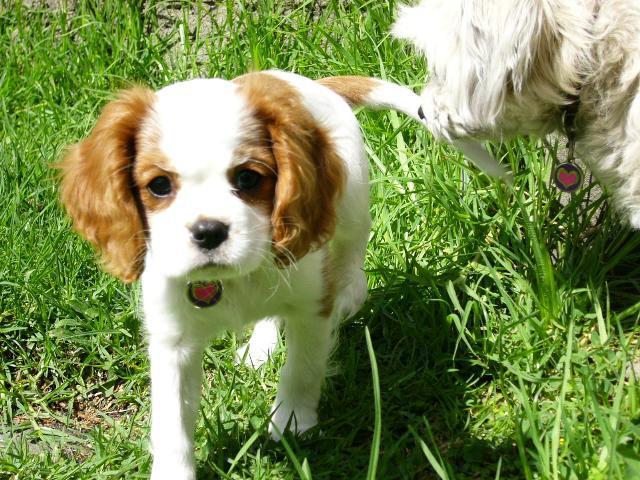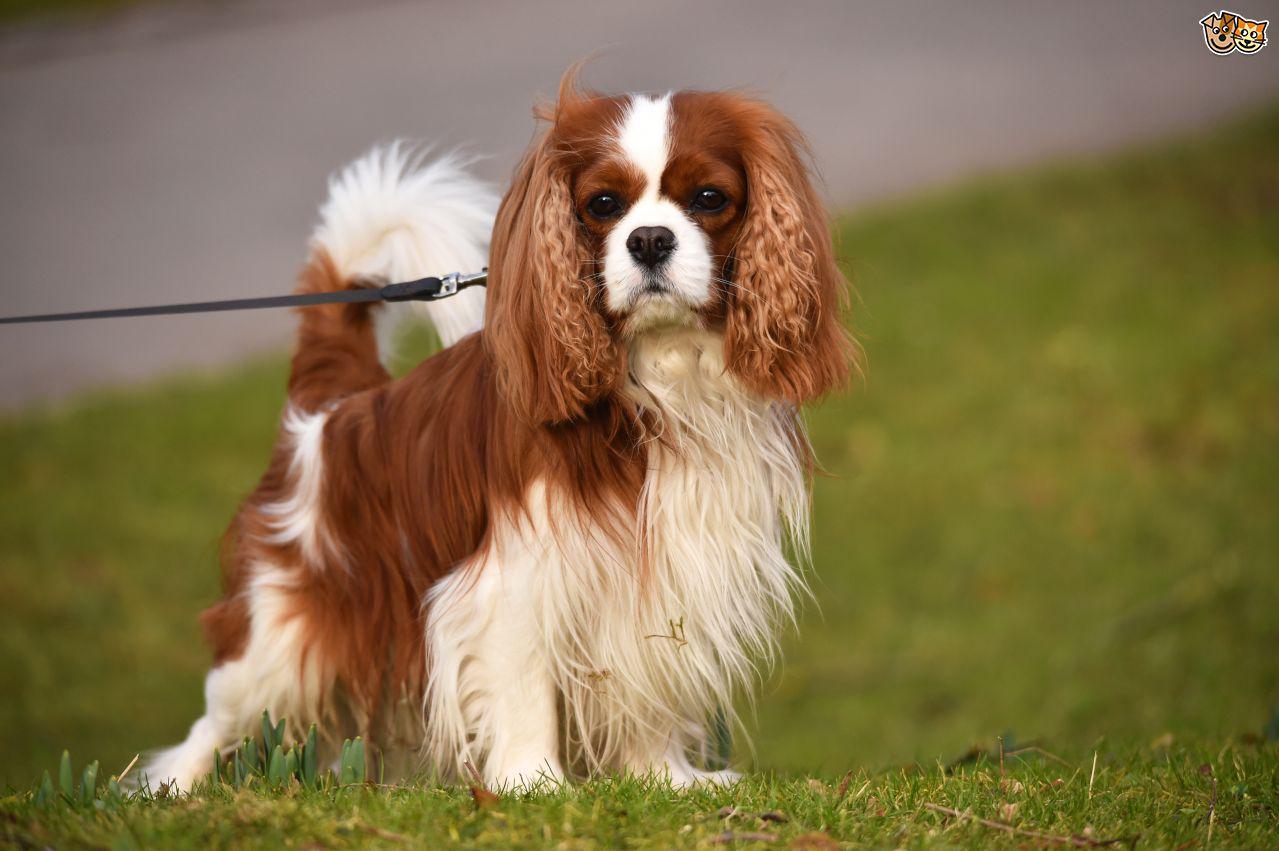The first image is the image on the left, the second image is the image on the right. For the images shown, is this caption "Two dogs on grassy ground are visible in the left image." true? Answer yes or no. Yes. The first image is the image on the left, the second image is the image on the right. Given the left and right images, does the statement "The dog on the right is standing in the grass." hold true? Answer yes or no. Yes. 